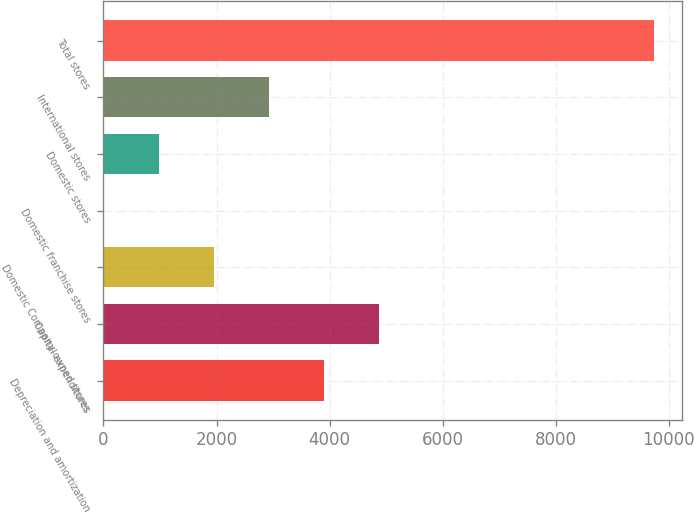Convert chart to OTSL. <chart><loc_0><loc_0><loc_500><loc_500><bar_chart><fcel>Depreciation and amortization<fcel>Capital expenditures<fcel>Domestic Company-owned stores<fcel>Domestic franchise stores<fcel>Domestic stores<fcel>International stores<fcel>Total stores<nl><fcel>3898.84<fcel>4872.7<fcel>1951.12<fcel>3.4<fcel>977.26<fcel>2924.98<fcel>9742<nl></chart> 